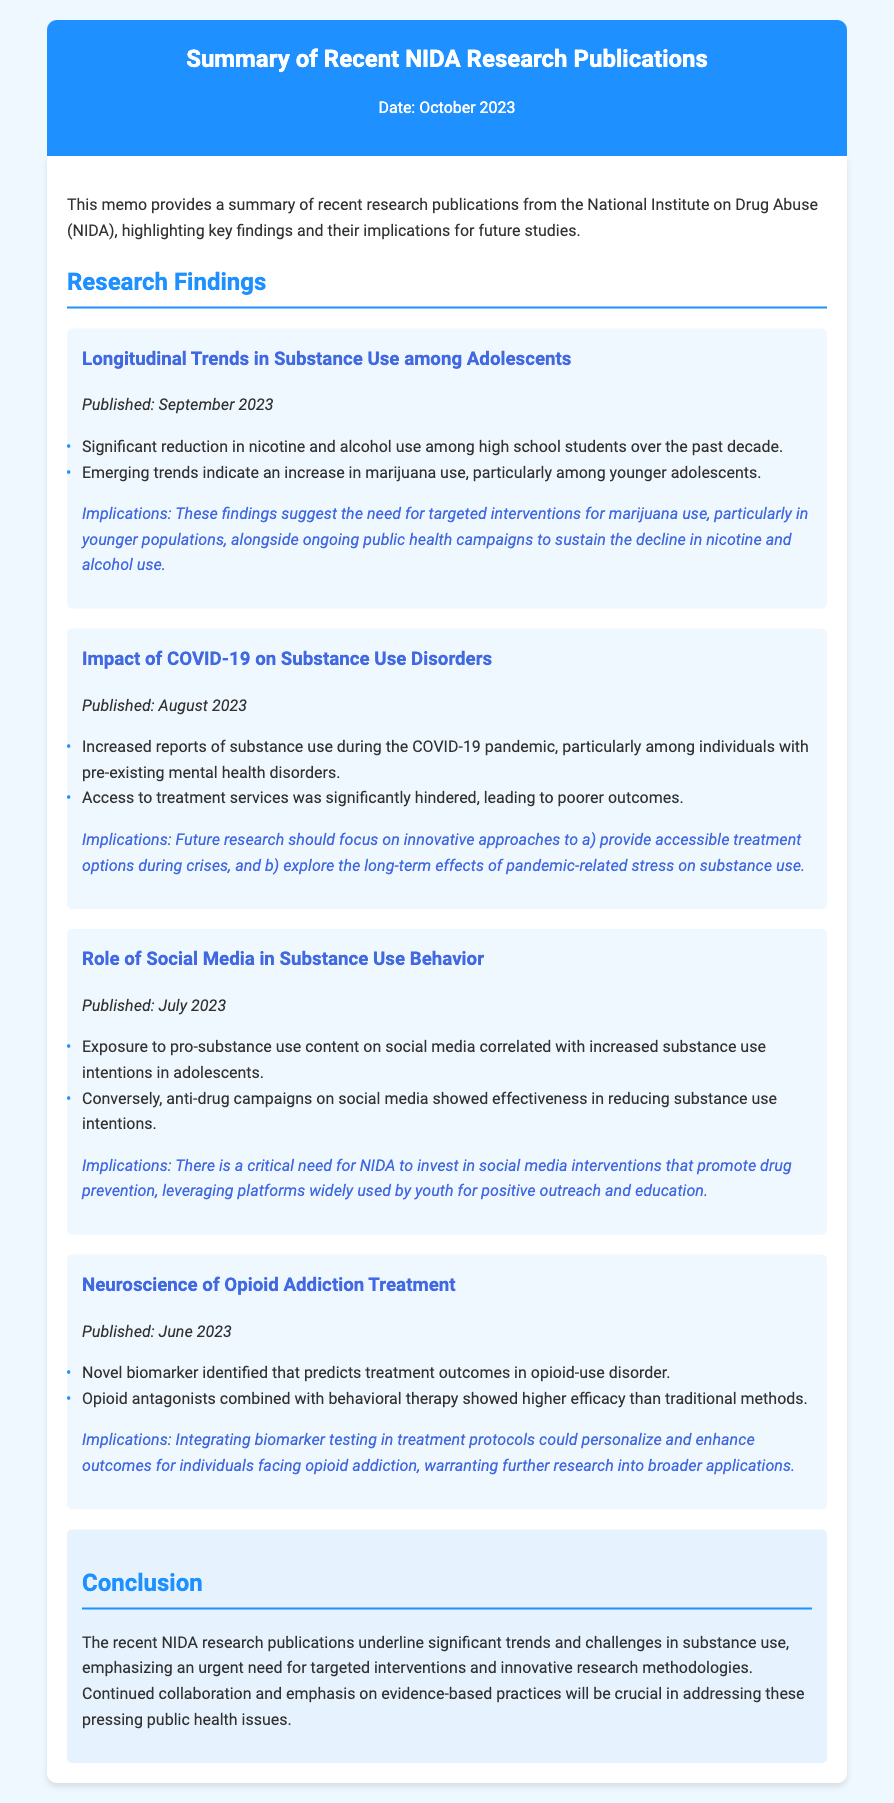what is the title of the memo? The title of the memo is stated at the top and summarizes the content regarding research publications from NIDA.
Answer: Summary of Recent NIDA Research Publications when was the memo published? The date provided in the memo indicates when it was published.
Answer: October 2023 what significant reduction was found among high school students? This refers to the specific substance that showed a decline in use, as highlighted in the key findings.
Answer: nicotine and alcohol use which substance showed an increase in use among younger adolescents? This question pertains to the emerging trend mentioned in the findings related to substance use in adolescents.
Answer: marijuana what does the memo suggest as a need for future research regarding COVID-19? This is based on the implications provided under the findings related to the pandemic's effect on substance use.
Answer: innovative approaches what is the unique aspect identified for opioid-use disorder treatment? This relates to the notable discovery mentioned in the findings regarding treatment effectiveness.
Answer: novel biomarker how did anti-drug campaigns on social media perform according to the research? Similar to earlier explanations, this question refers to specific findings related to the effectiveness of campaigns on social media.
Answer: effectiveness in reducing substance use intentions what is emphasized as crucial in addressing public health issues in the conclusion? This question targets the final remarks in the memo summarizing the overall theme of the research findings.
Answer: evidence-based practices 